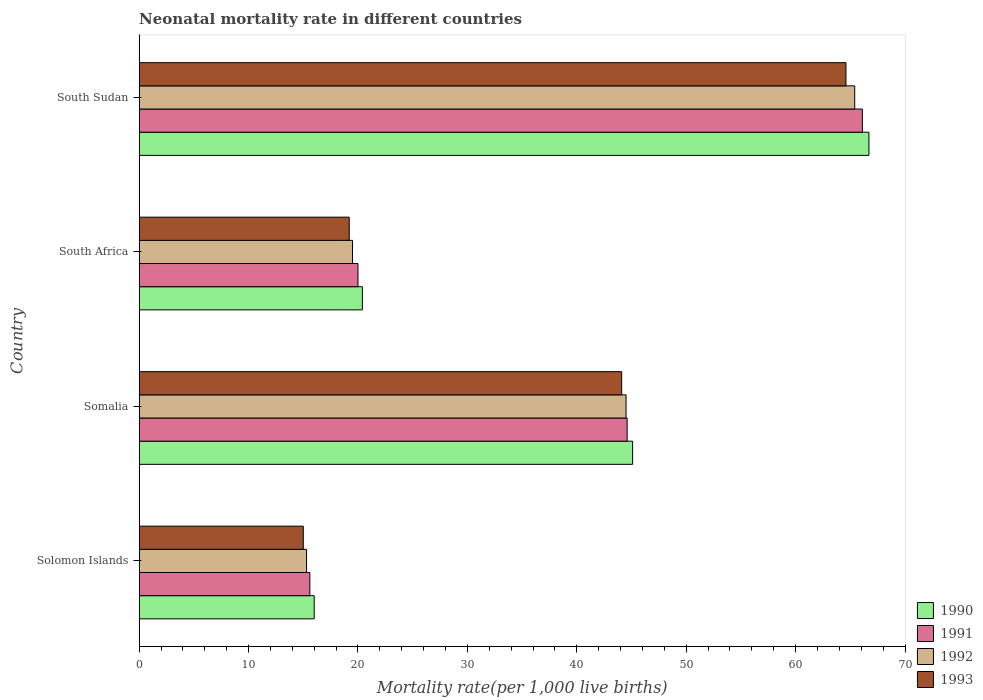Are the number of bars per tick equal to the number of legend labels?
Give a very brief answer. Yes. How many bars are there on the 2nd tick from the top?
Give a very brief answer. 4. What is the label of the 1st group of bars from the top?
Offer a terse response. South Sudan. In how many cases, is the number of bars for a given country not equal to the number of legend labels?
Make the answer very short. 0. What is the neonatal mortality rate in 1993 in South Sudan?
Provide a succinct answer. 64.6. Across all countries, what is the maximum neonatal mortality rate in 1990?
Offer a terse response. 66.7. In which country was the neonatal mortality rate in 1990 maximum?
Give a very brief answer. South Sudan. In which country was the neonatal mortality rate in 1993 minimum?
Ensure brevity in your answer.  Solomon Islands. What is the total neonatal mortality rate in 1991 in the graph?
Offer a very short reply. 146.3. What is the difference between the neonatal mortality rate in 1991 in South Africa and that in South Sudan?
Provide a short and direct response. -46.1. What is the difference between the neonatal mortality rate in 1993 in Solomon Islands and the neonatal mortality rate in 1990 in South Africa?
Your answer should be compact. -5.4. What is the average neonatal mortality rate in 1990 per country?
Offer a very short reply. 37.05. What is the difference between the neonatal mortality rate in 1991 and neonatal mortality rate in 1993 in South Africa?
Give a very brief answer. 0.8. What is the ratio of the neonatal mortality rate in 1990 in South Africa to that in South Sudan?
Your response must be concise. 0.31. Is the neonatal mortality rate in 1990 in Solomon Islands less than that in Somalia?
Provide a succinct answer. Yes. Is the difference between the neonatal mortality rate in 1991 in Somalia and South Africa greater than the difference between the neonatal mortality rate in 1993 in Somalia and South Africa?
Make the answer very short. No. What is the difference between the highest and the second highest neonatal mortality rate in 1993?
Offer a terse response. 20.5. What is the difference between the highest and the lowest neonatal mortality rate in 1990?
Offer a very short reply. 50.7. Is it the case that in every country, the sum of the neonatal mortality rate in 1990 and neonatal mortality rate in 1991 is greater than the neonatal mortality rate in 1993?
Your answer should be very brief. Yes. How many bars are there?
Your answer should be compact. 16. Are all the bars in the graph horizontal?
Offer a terse response. Yes. Does the graph contain grids?
Ensure brevity in your answer.  No. How many legend labels are there?
Ensure brevity in your answer.  4. How are the legend labels stacked?
Provide a short and direct response. Vertical. What is the title of the graph?
Your answer should be very brief. Neonatal mortality rate in different countries. What is the label or title of the X-axis?
Provide a short and direct response. Mortality rate(per 1,0 live births). What is the label or title of the Y-axis?
Your response must be concise. Country. What is the Mortality rate(per 1,000 live births) of 1990 in Solomon Islands?
Offer a terse response. 16. What is the Mortality rate(per 1,000 live births) of 1991 in Solomon Islands?
Give a very brief answer. 15.6. What is the Mortality rate(per 1,000 live births) in 1992 in Solomon Islands?
Provide a short and direct response. 15.3. What is the Mortality rate(per 1,000 live births) of 1993 in Solomon Islands?
Your answer should be very brief. 15. What is the Mortality rate(per 1,000 live births) of 1990 in Somalia?
Make the answer very short. 45.1. What is the Mortality rate(per 1,000 live births) of 1991 in Somalia?
Provide a short and direct response. 44.6. What is the Mortality rate(per 1,000 live births) of 1992 in Somalia?
Offer a very short reply. 44.5. What is the Mortality rate(per 1,000 live births) in 1993 in Somalia?
Give a very brief answer. 44.1. What is the Mortality rate(per 1,000 live births) of 1990 in South Africa?
Give a very brief answer. 20.4. What is the Mortality rate(per 1,000 live births) in 1991 in South Africa?
Provide a short and direct response. 20. What is the Mortality rate(per 1,000 live births) in 1990 in South Sudan?
Provide a succinct answer. 66.7. What is the Mortality rate(per 1,000 live births) of 1991 in South Sudan?
Provide a succinct answer. 66.1. What is the Mortality rate(per 1,000 live births) of 1992 in South Sudan?
Offer a very short reply. 65.4. What is the Mortality rate(per 1,000 live births) in 1993 in South Sudan?
Provide a succinct answer. 64.6. Across all countries, what is the maximum Mortality rate(per 1,000 live births) of 1990?
Provide a short and direct response. 66.7. Across all countries, what is the maximum Mortality rate(per 1,000 live births) of 1991?
Your answer should be compact. 66.1. Across all countries, what is the maximum Mortality rate(per 1,000 live births) of 1992?
Your answer should be compact. 65.4. Across all countries, what is the maximum Mortality rate(per 1,000 live births) of 1993?
Offer a very short reply. 64.6. Across all countries, what is the minimum Mortality rate(per 1,000 live births) of 1991?
Offer a terse response. 15.6. Across all countries, what is the minimum Mortality rate(per 1,000 live births) in 1992?
Keep it short and to the point. 15.3. Across all countries, what is the minimum Mortality rate(per 1,000 live births) of 1993?
Give a very brief answer. 15. What is the total Mortality rate(per 1,000 live births) in 1990 in the graph?
Make the answer very short. 148.2. What is the total Mortality rate(per 1,000 live births) of 1991 in the graph?
Keep it short and to the point. 146.3. What is the total Mortality rate(per 1,000 live births) in 1992 in the graph?
Offer a terse response. 144.7. What is the total Mortality rate(per 1,000 live births) in 1993 in the graph?
Offer a very short reply. 142.9. What is the difference between the Mortality rate(per 1,000 live births) in 1990 in Solomon Islands and that in Somalia?
Keep it short and to the point. -29.1. What is the difference between the Mortality rate(per 1,000 live births) in 1991 in Solomon Islands and that in Somalia?
Provide a succinct answer. -29. What is the difference between the Mortality rate(per 1,000 live births) of 1992 in Solomon Islands and that in Somalia?
Offer a very short reply. -29.2. What is the difference between the Mortality rate(per 1,000 live births) of 1993 in Solomon Islands and that in Somalia?
Make the answer very short. -29.1. What is the difference between the Mortality rate(per 1,000 live births) of 1990 in Solomon Islands and that in South Africa?
Your answer should be very brief. -4.4. What is the difference between the Mortality rate(per 1,000 live births) of 1992 in Solomon Islands and that in South Africa?
Provide a short and direct response. -4.2. What is the difference between the Mortality rate(per 1,000 live births) of 1993 in Solomon Islands and that in South Africa?
Provide a short and direct response. -4.2. What is the difference between the Mortality rate(per 1,000 live births) of 1990 in Solomon Islands and that in South Sudan?
Ensure brevity in your answer.  -50.7. What is the difference between the Mortality rate(per 1,000 live births) of 1991 in Solomon Islands and that in South Sudan?
Make the answer very short. -50.5. What is the difference between the Mortality rate(per 1,000 live births) of 1992 in Solomon Islands and that in South Sudan?
Your response must be concise. -50.1. What is the difference between the Mortality rate(per 1,000 live births) in 1993 in Solomon Islands and that in South Sudan?
Make the answer very short. -49.6. What is the difference between the Mortality rate(per 1,000 live births) in 1990 in Somalia and that in South Africa?
Offer a terse response. 24.7. What is the difference between the Mortality rate(per 1,000 live births) of 1991 in Somalia and that in South Africa?
Offer a very short reply. 24.6. What is the difference between the Mortality rate(per 1,000 live births) in 1993 in Somalia and that in South Africa?
Your response must be concise. 24.9. What is the difference between the Mortality rate(per 1,000 live births) in 1990 in Somalia and that in South Sudan?
Provide a succinct answer. -21.6. What is the difference between the Mortality rate(per 1,000 live births) of 1991 in Somalia and that in South Sudan?
Ensure brevity in your answer.  -21.5. What is the difference between the Mortality rate(per 1,000 live births) in 1992 in Somalia and that in South Sudan?
Offer a terse response. -20.9. What is the difference between the Mortality rate(per 1,000 live births) of 1993 in Somalia and that in South Sudan?
Offer a terse response. -20.5. What is the difference between the Mortality rate(per 1,000 live births) in 1990 in South Africa and that in South Sudan?
Your response must be concise. -46.3. What is the difference between the Mortality rate(per 1,000 live births) of 1991 in South Africa and that in South Sudan?
Your answer should be very brief. -46.1. What is the difference between the Mortality rate(per 1,000 live births) of 1992 in South Africa and that in South Sudan?
Keep it short and to the point. -45.9. What is the difference between the Mortality rate(per 1,000 live births) of 1993 in South Africa and that in South Sudan?
Keep it short and to the point. -45.4. What is the difference between the Mortality rate(per 1,000 live births) of 1990 in Solomon Islands and the Mortality rate(per 1,000 live births) of 1991 in Somalia?
Provide a succinct answer. -28.6. What is the difference between the Mortality rate(per 1,000 live births) of 1990 in Solomon Islands and the Mortality rate(per 1,000 live births) of 1992 in Somalia?
Provide a succinct answer. -28.5. What is the difference between the Mortality rate(per 1,000 live births) of 1990 in Solomon Islands and the Mortality rate(per 1,000 live births) of 1993 in Somalia?
Provide a short and direct response. -28.1. What is the difference between the Mortality rate(per 1,000 live births) in 1991 in Solomon Islands and the Mortality rate(per 1,000 live births) in 1992 in Somalia?
Make the answer very short. -28.9. What is the difference between the Mortality rate(per 1,000 live births) of 1991 in Solomon Islands and the Mortality rate(per 1,000 live births) of 1993 in Somalia?
Keep it short and to the point. -28.5. What is the difference between the Mortality rate(per 1,000 live births) in 1992 in Solomon Islands and the Mortality rate(per 1,000 live births) in 1993 in Somalia?
Provide a short and direct response. -28.8. What is the difference between the Mortality rate(per 1,000 live births) in 1990 in Solomon Islands and the Mortality rate(per 1,000 live births) in 1991 in South Africa?
Your answer should be compact. -4. What is the difference between the Mortality rate(per 1,000 live births) in 1990 in Solomon Islands and the Mortality rate(per 1,000 live births) in 1992 in South Africa?
Your response must be concise. -3.5. What is the difference between the Mortality rate(per 1,000 live births) of 1991 in Solomon Islands and the Mortality rate(per 1,000 live births) of 1992 in South Africa?
Give a very brief answer. -3.9. What is the difference between the Mortality rate(per 1,000 live births) of 1991 in Solomon Islands and the Mortality rate(per 1,000 live births) of 1993 in South Africa?
Offer a very short reply. -3.6. What is the difference between the Mortality rate(per 1,000 live births) of 1992 in Solomon Islands and the Mortality rate(per 1,000 live births) of 1993 in South Africa?
Provide a short and direct response. -3.9. What is the difference between the Mortality rate(per 1,000 live births) in 1990 in Solomon Islands and the Mortality rate(per 1,000 live births) in 1991 in South Sudan?
Your answer should be very brief. -50.1. What is the difference between the Mortality rate(per 1,000 live births) of 1990 in Solomon Islands and the Mortality rate(per 1,000 live births) of 1992 in South Sudan?
Make the answer very short. -49.4. What is the difference between the Mortality rate(per 1,000 live births) in 1990 in Solomon Islands and the Mortality rate(per 1,000 live births) in 1993 in South Sudan?
Ensure brevity in your answer.  -48.6. What is the difference between the Mortality rate(per 1,000 live births) in 1991 in Solomon Islands and the Mortality rate(per 1,000 live births) in 1992 in South Sudan?
Offer a very short reply. -49.8. What is the difference between the Mortality rate(per 1,000 live births) in 1991 in Solomon Islands and the Mortality rate(per 1,000 live births) in 1993 in South Sudan?
Keep it short and to the point. -49. What is the difference between the Mortality rate(per 1,000 live births) in 1992 in Solomon Islands and the Mortality rate(per 1,000 live births) in 1993 in South Sudan?
Offer a terse response. -49.3. What is the difference between the Mortality rate(per 1,000 live births) in 1990 in Somalia and the Mortality rate(per 1,000 live births) in 1991 in South Africa?
Give a very brief answer. 25.1. What is the difference between the Mortality rate(per 1,000 live births) in 1990 in Somalia and the Mortality rate(per 1,000 live births) in 1992 in South Africa?
Give a very brief answer. 25.6. What is the difference between the Mortality rate(per 1,000 live births) in 1990 in Somalia and the Mortality rate(per 1,000 live births) in 1993 in South Africa?
Offer a very short reply. 25.9. What is the difference between the Mortality rate(per 1,000 live births) in 1991 in Somalia and the Mortality rate(per 1,000 live births) in 1992 in South Africa?
Offer a very short reply. 25.1. What is the difference between the Mortality rate(per 1,000 live births) of 1991 in Somalia and the Mortality rate(per 1,000 live births) of 1993 in South Africa?
Ensure brevity in your answer.  25.4. What is the difference between the Mortality rate(per 1,000 live births) of 1992 in Somalia and the Mortality rate(per 1,000 live births) of 1993 in South Africa?
Provide a short and direct response. 25.3. What is the difference between the Mortality rate(per 1,000 live births) in 1990 in Somalia and the Mortality rate(per 1,000 live births) in 1992 in South Sudan?
Ensure brevity in your answer.  -20.3. What is the difference between the Mortality rate(per 1,000 live births) in 1990 in Somalia and the Mortality rate(per 1,000 live births) in 1993 in South Sudan?
Give a very brief answer. -19.5. What is the difference between the Mortality rate(per 1,000 live births) in 1991 in Somalia and the Mortality rate(per 1,000 live births) in 1992 in South Sudan?
Offer a very short reply. -20.8. What is the difference between the Mortality rate(per 1,000 live births) of 1992 in Somalia and the Mortality rate(per 1,000 live births) of 1993 in South Sudan?
Give a very brief answer. -20.1. What is the difference between the Mortality rate(per 1,000 live births) in 1990 in South Africa and the Mortality rate(per 1,000 live births) in 1991 in South Sudan?
Your answer should be very brief. -45.7. What is the difference between the Mortality rate(per 1,000 live births) in 1990 in South Africa and the Mortality rate(per 1,000 live births) in 1992 in South Sudan?
Offer a terse response. -45. What is the difference between the Mortality rate(per 1,000 live births) of 1990 in South Africa and the Mortality rate(per 1,000 live births) of 1993 in South Sudan?
Make the answer very short. -44.2. What is the difference between the Mortality rate(per 1,000 live births) of 1991 in South Africa and the Mortality rate(per 1,000 live births) of 1992 in South Sudan?
Make the answer very short. -45.4. What is the difference between the Mortality rate(per 1,000 live births) in 1991 in South Africa and the Mortality rate(per 1,000 live births) in 1993 in South Sudan?
Ensure brevity in your answer.  -44.6. What is the difference between the Mortality rate(per 1,000 live births) in 1992 in South Africa and the Mortality rate(per 1,000 live births) in 1993 in South Sudan?
Offer a very short reply. -45.1. What is the average Mortality rate(per 1,000 live births) in 1990 per country?
Make the answer very short. 37.05. What is the average Mortality rate(per 1,000 live births) of 1991 per country?
Offer a terse response. 36.58. What is the average Mortality rate(per 1,000 live births) of 1992 per country?
Provide a short and direct response. 36.17. What is the average Mortality rate(per 1,000 live births) of 1993 per country?
Ensure brevity in your answer.  35.73. What is the difference between the Mortality rate(per 1,000 live births) of 1990 and Mortality rate(per 1,000 live births) of 1991 in Solomon Islands?
Your response must be concise. 0.4. What is the difference between the Mortality rate(per 1,000 live births) in 1990 and Mortality rate(per 1,000 live births) in 1992 in Solomon Islands?
Give a very brief answer. 0.7. What is the difference between the Mortality rate(per 1,000 live births) of 1990 and Mortality rate(per 1,000 live births) of 1993 in Solomon Islands?
Offer a very short reply. 1. What is the difference between the Mortality rate(per 1,000 live births) of 1991 and Mortality rate(per 1,000 live births) of 1992 in Solomon Islands?
Make the answer very short. 0.3. What is the difference between the Mortality rate(per 1,000 live births) in 1992 and Mortality rate(per 1,000 live births) in 1993 in Solomon Islands?
Your response must be concise. 0.3. What is the difference between the Mortality rate(per 1,000 live births) in 1990 and Mortality rate(per 1,000 live births) in 1991 in Somalia?
Offer a terse response. 0.5. What is the difference between the Mortality rate(per 1,000 live births) in 1990 and Mortality rate(per 1,000 live births) in 1993 in Somalia?
Provide a short and direct response. 1. What is the difference between the Mortality rate(per 1,000 live births) of 1991 and Mortality rate(per 1,000 live births) of 1992 in Somalia?
Ensure brevity in your answer.  0.1. What is the difference between the Mortality rate(per 1,000 live births) of 1991 and Mortality rate(per 1,000 live births) of 1993 in Somalia?
Offer a very short reply. 0.5. What is the difference between the Mortality rate(per 1,000 live births) of 1991 and Mortality rate(per 1,000 live births) of 1993 in South Africa?
Make the answer very short. 0.8. What is the difference between the Mortality rate(per 1,000 live births) in 1992 and Mortality rate(per 1,000 live births) in 1993 in South Africa?
Ensure brevity in your answer.  0.3. What is the difference between the Mortality rate(per 1,000 live births) in 1990 and Mortality rate(per 1,000 live births) in 1991 in South Sudan?
Provide a succinct answer. 0.6. What is the difference between the Mortality rate(per 1,000 live births) of 1990 and Mortality rate(per 1,000 live births) of 1992 in South Sudan?
Your answer should be very brief. 1.3. What is the difference between the Mortality rate(per 1,000 live births) in 1991 and Mortality rate(per 1,000 live births) in 1992 in South Sudan?
Offer a terse response. 0.7. What is the ratio of the Mortality rate(per 1,000 live births) of 1990 in Solomon Islands to that in Somalia?
Offer a very short reply. 0.35. What is the ratio of the Mortality rate(per 1,000 live births) in 1991 in Solomon Islands to that in Somalia?
Your answer should be compact. 0.35. What is the ratio of the Mortality rate(per 1,000 live births) of 1992 in Solomon Islands to that in Somalia?
Ensure brevity in your answer.  0.34. What is the ratio of the Mortality rate(per 1,000 live births) in 1993 in Solomon Islands to that in Somalia?
Ensure brevity in your answer.  0.34. What is the ratio of the Mortality rate(per 1,000 live births) of 1990 in Solomon Islands to that in South Africa?
Offer a very short reply. 0.78. What is the ratio of the Mortality rate(per 1,000 live births) in 1991 in Solomon Islands to that in South Africa?
Your response must be concise. 0.78. What is the ratio of the Mortality rate(per 1,000 live births) of 1992 in Solomon Islands to that in South Africa?
Provide a short and direct response. 0.78. What is the ratio of the Mortality rate(per 1,000 live births) of 1993 in Solomon Islands to that in South Africa?
Offer a terse response. 0.78. What is the ratio of the Mortality rate(per 1,000 live births) of 1990 in Solomon Islands to that in South Sudan?
Your answer should be very brief. 0.24. What is the ratio of the Mortality rate(per 1,000 live births) in 1991 in Solomon Islands to that in South Sudan?
Make the answer very short. 0.24. What is the ratio of the Mortality rate(per 1,000 live births) in 1992 in Solomon Islands to that in South Sudan?
Your response must be concise. 0.23. What is the ratio of the Mortality rate(per 1,000 live births) in 1993 in Solomon Islands to that in South Sudan?
Keep it short and to the point. 0.23. What is the ratio of the Mortality rate(per 1,000 live births) in 1990 in Somalia to that in South Africa?
Provide a short and direct response. 2.21. What is the ratio of the Mortality rate(per 1,000 live births) in 1991 in Somalia to that in South Africa?
Ensure brevity in your answer.  2.23. What is the ratio of the Mortality rate(per 1,000 live births) of 1992 in Somalia to that in South Africa?
Provide a succinct answer. 2.28. What is the ratio of the Mortality rate(per 1,000 live births) in 1993 in Somalia to that in South Africa?
Make the answer very short. 2.3. What is the ratio of the Mortality rate(per 1,000 live births) in 1990 in Somalia to that in South Sudan?
Make the answer very short. 0.68. What is the ratio of the Mortality rate(per 1,000 live births) of 1991 in Somalia to that in South Sudan?
Offer a very short reply. 0.67. What is the ratio of the Mortality rate(per 1,000 live births) of 1992 in Somalia to that in South Sudan?
Make the answer very short. 0.68. What is the ratio of the Mortality rate(per 1,000 live births) in 1993 in Somalia to that in South Sudan?
Your response must be concise. 0.68. What is the ratio of the Mortality rate(per 1,000 live births) in 1990 in South Africa to that in South Sudan?
Your response must be concise. 0.31. What is the ratio of the Mortality rate(per 1,000 live births) of 1991 in South Africa to that in South Sudan?
Offer a terse response. 0.3. What is the ratio of the Mortality rate(per 1,000 live births) of 1992 in South Africa to that in South Sudan?
Ensure brevity in your answer.  0.3. What is the ratio of the Mortality rate(per 1,000 live births) in 1993 in South Africa to that in South Sudan?
Your answer should be compact. 0.3. What is the difference between the highest and the second highest Mortality rate(per 1,000 live births) in 1990?
Provide a succinct answer. 21.6. What is the difference between the highest and the second highest Mortality rate(per 1,000 live births) of 1991?
Provide a short and direct response. 21.5. What is the difference between the highest and the second highest Mortality rate(per 1,000 live births) of 1992?
Make the answer very short. 20.9. What is the difference between the highest and the lowest Mortality rate(per 1,000 live births) in 1990?
Ensure brevity in your answer.  50.7. What is the difference between the highest and the lowest Mortality rate(per 1,000 live births) in 1991?
Give a very brief answer. 50.5. What is the difference between the highest and the lowest Mortality rate(per 1,000 live births) in 1992?
Keep it short and to the point. 50.1. What is the difference between the highest and the lowest Mortality rate(per 1,000 live births) of 1993?
Your answer should be compact. 49.6. 